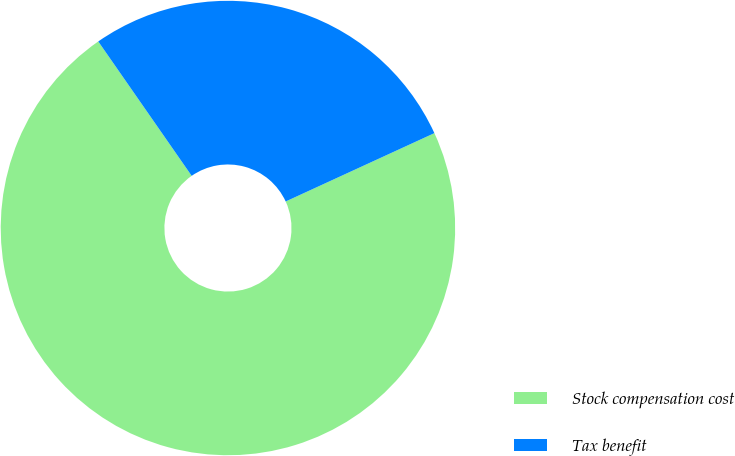Convert chart. <chart><loc_0><loc_0><loc_500><loc_500><pie_chart><fcel>Stock compensation cost<fcel>Tax benefit<nl><fcel>72.19%<fcel>27.81%<nl></chart> 